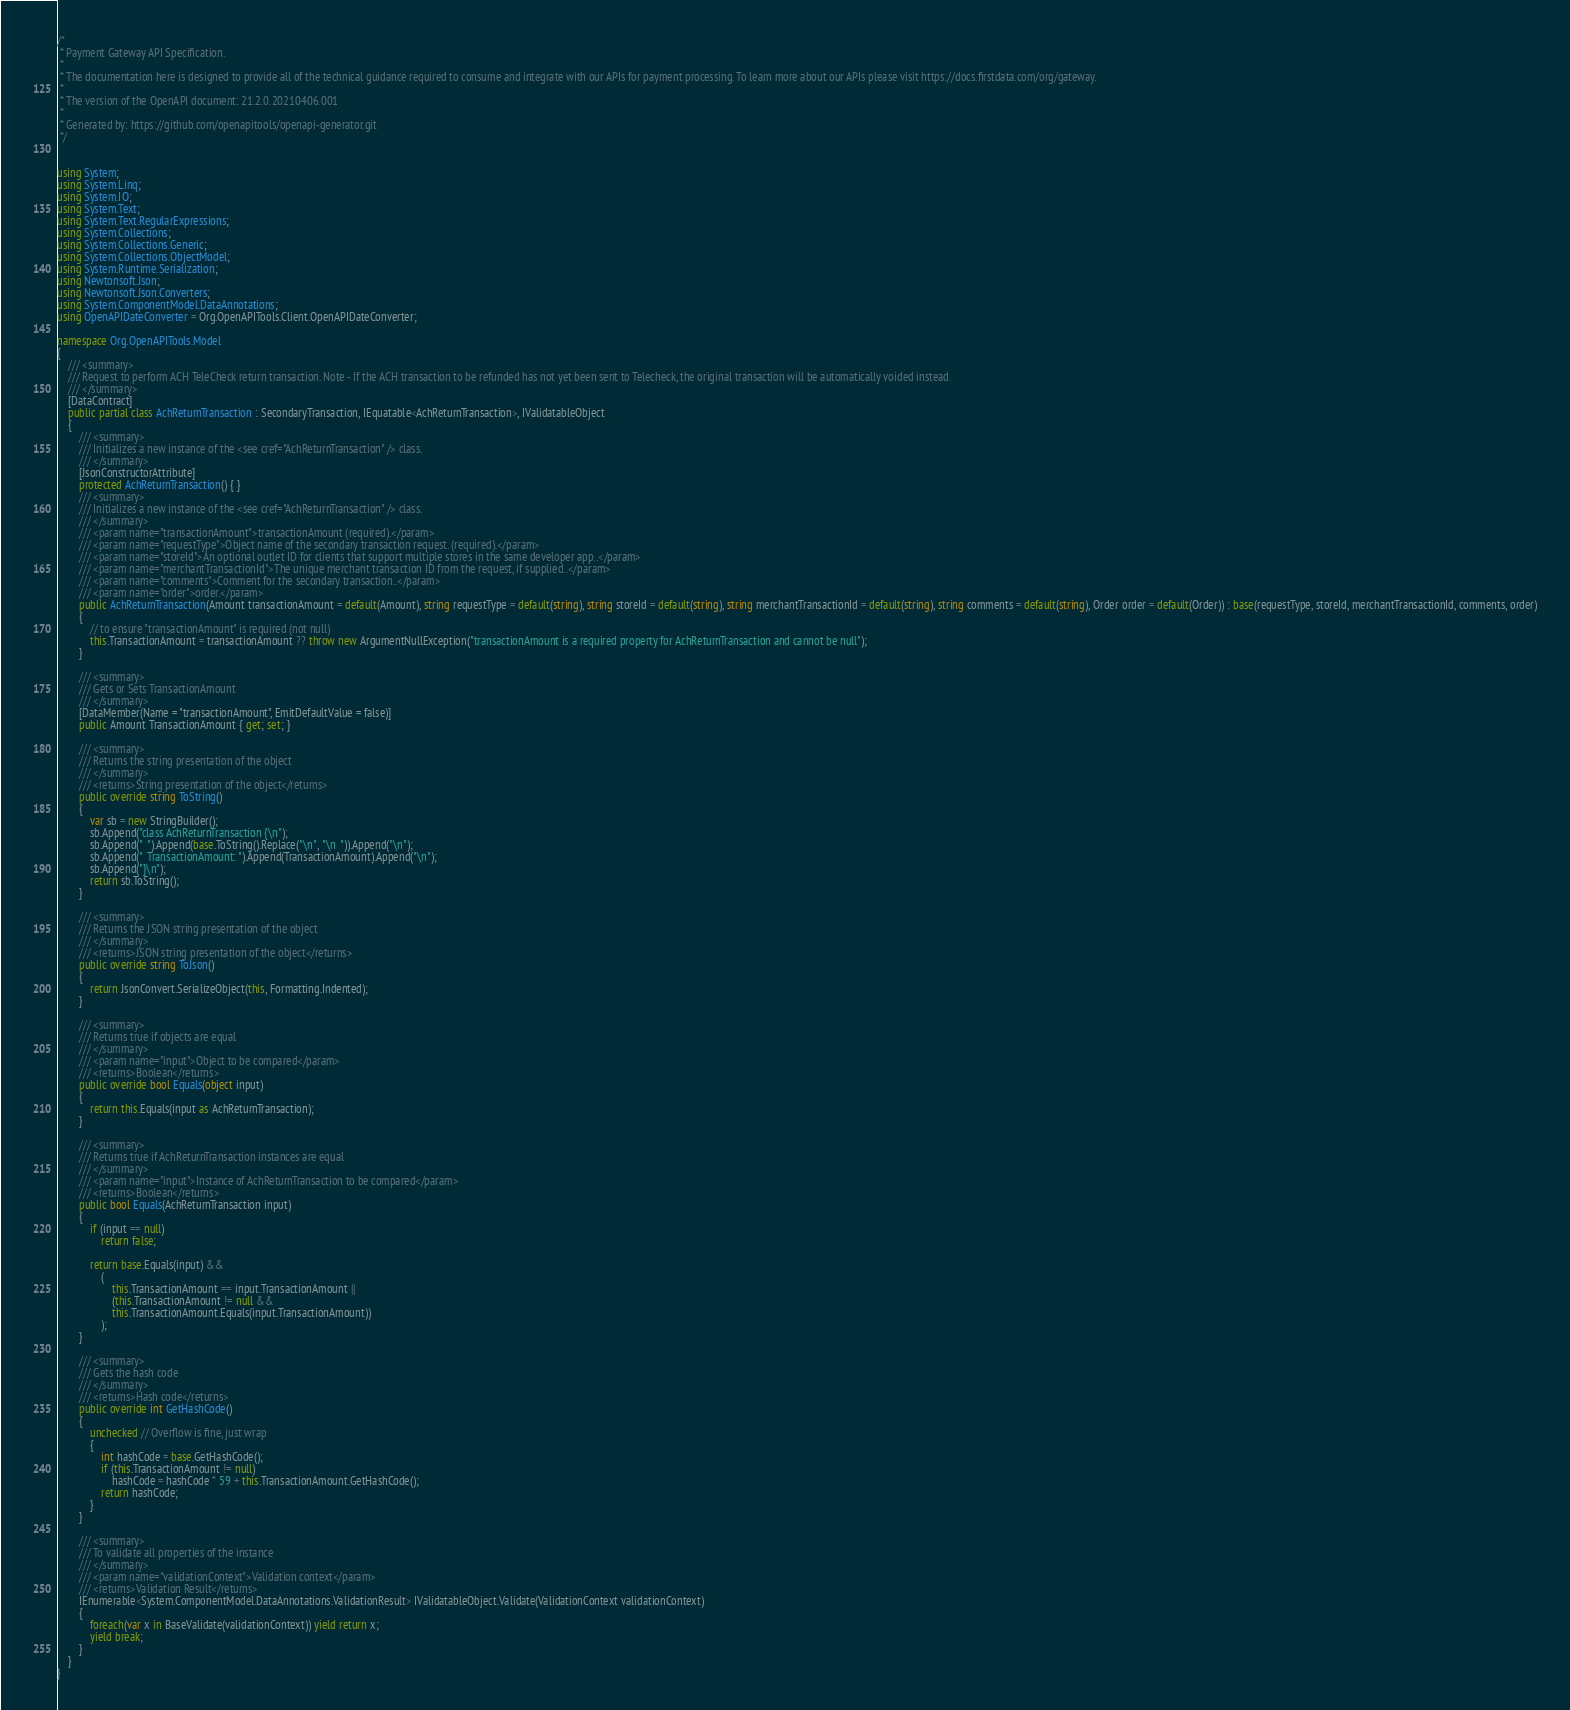Convert code to text. <code><loc_0><loc_0><loc_500><loc_500><_C#_>/* 
 * Payment Gateway API Specification.
 *
 * The documentation here is designed to provide all of the technical guidance required to consume and integrate with our APIs for payment processing. To learn more about our APIs please visit https://docs.firstdata.com/org/gateway.
 *
 * The version of the OpenAPI document: 21.2.0.20210406.001
 * 
 * Generated by: https://github.com/openapitools/openapi-generator.git
 */


using System;
using System.Linq;
using System.IO;
using System.Text;
using System.Text.RegularExpressions;
using System.Collections;
using System.Collections.Generic;
using System.Collections.ObjectModel;
using System.Runtime.Serialization;
using Newtonsoft.Json;
using Newtonsoft.Json.Converters;
using System.ComponentModel.DataAnnotations;
using OpenAPIDateConverter = Org.OpenAPITools.Client.OpenAPIDateConverter;

namespace Org.OpenAPITools.Model
{
    /// <summary>
    /// Request to perform ACH TeleCheck return transaction. Note - If the ACH transaction to be refunded has not yet been sent to Telecheck, the original transaction will be automatically voided instead.
    /// </summary>
    [DataContract]
    public partial class AchReturnTransaction : SecondaryTransaction, IEquatable<AchReturnTransaction>, IValidatableObject
    {
        /// <summary>
        /// Initializes a new instance of the <see cref="AchReturnTransaction" /> class.
        /// </summary>
        [JsonConstructorAttribute]
        protected AchReturnTransaction() { }
        /// <summary>
        /// Initializes a new instance of the <see cref="AchReturnTransaction" /> class.
        /// </summary>
        /// <param name="transactionAmount">transactionAmount (required).</param>
        /// <param name="requestType">Object name of the secondary transaction request. (required).</param>
        /// <param name="storeId">An optional outlet ID for clients that support multiple stores in the same developer app..</param>
        /// <param name="merchantTransactionId">The unique merchant transaction ID from the request, if supplied..</param>
        /// <param name="comments">Comment for the secondary transaction..</param>
        /// <param name="order">order.</param>
        public AchReturnTransaction(Amount transactionAmount = default(Amount), string requestType = default(string), string storeId = default(string), string merchantTransactionId = default(string), string comments = default(string), Order order = default(Order)) : base(requestType, storeId, merchantTransactionId, comments, order)
        {
            // to ensure "transactionAmount" is required (not null)
            this.TransactionAmount = transactionAmount ?? throw new ArgumentNullException("transactionAmount is a required property for AchReturnTransaction and cannot be null");
        }

        /// <summary>
        /// Gets or Sets TransactionAmount
        /// </summary>
        [DataMember(Name = "transactionAmount", EmitDefaultValue = false)]
        public Amount TransactionAmount { get; set; }

        /// <summary>
        /// Returns the string presentation of the object
        /// </summary>
        /// <returns>String presentation of the object</returns>
        public override string ToString()
        {
            var sb = new StringBuilder();
            sb.Append("class AchReturnTransaction {\n");
            sb.Append("  ").Append(base.ToString().Replace("\n", "\n  ")).Append("\n");
            sb.Append("  TransactionAmount: ").Append(TransactionAmount).Append("\n");
            sb.Append("}\n");
            return sb.ToString();
        }

        /// <summary>
        /// Returns the JSON string presentation of the object
        /// </summary>
        /// <returns>JSON string presentation of the object</returns>
        public override string ToJson()
        {
            return JsonConvert.SerializeObject(this, Formatting.Indented);
        }

        /// <summary>
        /// Returns true if objects are equal
        /// </summary>
        /// <param name="input">Object to be compared</param>
        /// <returns>Boolean</returns>
        public override bool Equals(object input)
        {
            return this.Equals(input as AchReturnTransaction);
        }

        /// <summary>
        /// Returns true if AchReturnTransaction instances are equal
        /// </summary>
        /// <param name="input">Instance of AchReturnTransaction to be compared</param>
        /// <returns>Boolean</returns>
        public bool Equals(AchReturnTransaction input)
        {
            if (input == null)
                return false;

            return base.Equals(input) && 
                (
                    this.TransactionAmount == input.TransactionAmount ||
                    (this.TransactionAmount != null &&
                    this.TransactionAmount.Equals(input.TransactionAmount))
                );
        }

        /// <summary>
        /// Gets the hash code
        /// </summary>
        /// <returns>Hash code</returns>
        public override int GetHashCode()
        {
            unchecked // Overflow is fine, just wrap
            {
                int hashCode = base.GetHashCode();
                if (this.TransactionAmount != null)
                    hashCode = hashCode * 59 + this.TransactionAmount.GetHashCode();
                return hashCode;
            }
        }

        /// <summary>
        /// To validate all properties of the instance
        /// </summary>
        /// <param name="validationContext">Validation context</param>
        /// <returns>Validation Result</returns>
        IEnumerable<System.ComponentModel.DataAnnotations.ValidationResult> IValidatableObject.Validate(ValidationContext validationContext)
        {
            foreach(var x in BaseValidate(validationContext)) yield return x;
            yield break;
        }
    }
}
</code> 